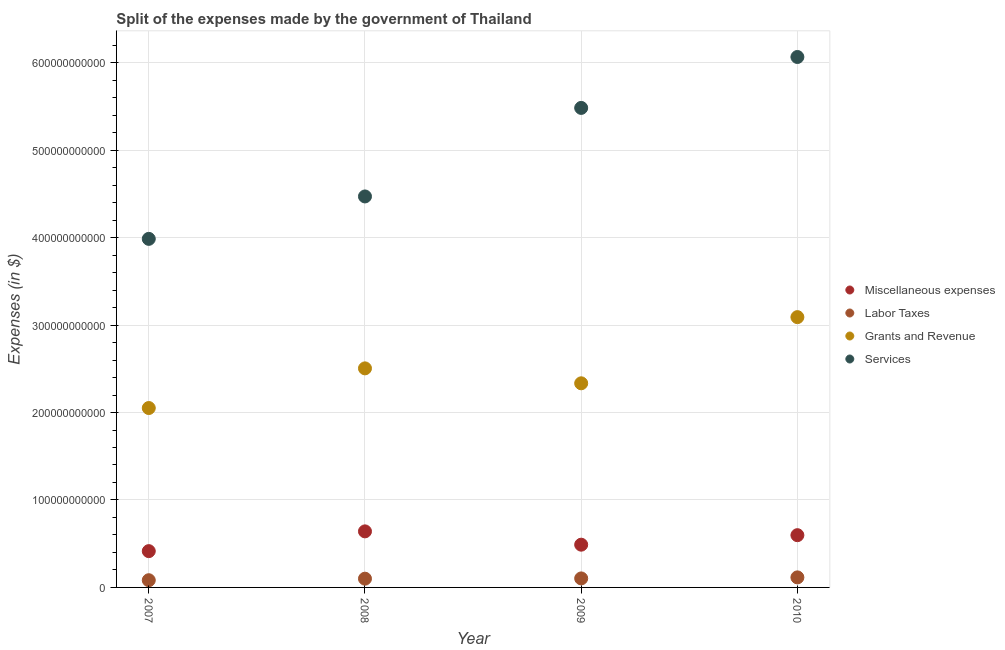Is the number of dotlines equal to the number of legend labels?
Your answer should be compact. Yes. Across all years, what is the maximum amount spent on labor taxes?
Make the answer very short. 1.15e+1. Across all years, what is the minimum amount spent on miscellaneous expenses?
Provide a short and direct response. 4.15e+1. In which year was the amount spent on services maximum?
Your answer should be very brief. 2010. In which year was the amount spent on miscellaneous expenses minimum?
Give a very brief answer. 2007. What is the total amount spent on labor taxes in the graph?
Your response must be concise. 4.00e+1. What is the difference between the amount spent on labor taxes in 2007 and that in 2008?
Your answer should be compact. -1.76e+09. What is the difference between the amount spent on services in 2010 and the amount spent on grants and revenue in 2008?
Your answer should be very brief. 3.56e+11. What is the average amount spent on miscellaneous expenses per year?
Give a very brief answer. 5.36e+1. In the year 2010, what is the difference between the amount spent on labor taxes and amount spent on miscellaneous expenses?
Provide a short and direct response. -4.83e+1. What is the ratio of the amount spent on grants and revenue in 2008 to that in 2010?
Provide a succinct answer. 0.81. Is the amount spent on miscellaneous expenses in 2008 less than that in 2010?
Your response must be concise. No. What is the difference between the highest and the second highest amount spent on services?
Provide a short and direct response. 5.82e+1. What is the difference between the highest and the lowest amount spent on labor taxes?
Give a very brief answer. 3.24e+09. Is the sum of the amount spent on labor taxes in 2009 and 2010 greater than the maximum amount spent on grants and revenue across all years?
Provide a succinct answer. No. Is it the case that in every year, the sum of the amount spent on miscellaneous expenses and amount spent on services is greater than the sum of amount spent on grants and revenue and amount spent on labor taxes?
Keep it short and to the point. Yes. Is it the case that in every year, the sum of the amount spent on miscellaneous expenses and amount spent on labor taxes is greater than the amount spent on grants and revenue?
Ensure brevity in your answer.  No. Does the amount spent on labor taxes monotonically increase over the years?
Your answer should be very brief. Yes. Is the amount spent on miscellaneous expenses strictly greater than the amount spent on labor taxes over the years?
Your answer should be very brief. Yes. Is the amount spent on labor taxes strictly less than the amount spent on miscellaneous expenses over the years?
Offer a terse response. Yes. How many dotlines are there?
Give a very brief answer. 4. What is the difference between two consecutive major ticks on the Y-axis?
Offer a very short reply. 1.00e+11. Does the graph contain any zero values?
Offer a terse response. No. Does the graph contain grids?
Provide a short and direct response. Yes. How many legend labels are there?
Provide a short and direct response. 4. How are the legend labels stacked?
Give a very brief answer. Vertical. What is the title of the graph?
Your answer should be compact. Split of the expenses made by the government of Thailand. What is the label or title of the X-axis?
Keep it short and to the point. Year. What is the label or title of the Y-axis?
Offer a terse response. Expenses (in $). What is the Expenses (in $) in Miscellaneous expenses in 2007?
Your answer should be very brief. 4.15e+1. What is the Expenses (in $) of Labor Taxes in 2007?
Your response must be concise. 8.24e+09. What is the Expenses (in $) of Grants and Revenue in 2007?
Provide a short and direct response. 2.05e+11. What is the Expenses (in $) of Services in 2007?
Your answer should be compact. 3.99e+11. What is the Expenses (in $) in Miscellaneous expenses in 2008?
Your answer should be very brief. 6.41e+1. What is the Expenses (in $) of Grants and Revenue in 2008?
Offer a terse response. 2.50e+11. What is the Expenses (in $) in Services in 2008?
Ensure brevity in your answer.  4.47e+11. What is the Expenses (in $) in Miscellaneous expenses in 2009?
Your answer should be very brief. 4.89e+1. What is the Expenses (in $) of Labor Taxes in 2009?
Provide a short and direct response. 1.03e+1. What is the Expenses (in $) in Grants and Revenue in 2009?
Provide a succinct answer. 2.33e+11. What is the Expenses (in $) of Services in 2009?
Keep it short and to the point. 5.48e+11. What is the Expenses (in $) of Miscellaneous expenses in 2010?
Ensure brevity in your answer.  5.98e+1. What is the Expenses (in $) of Labor Taxes in 2010?
Give a very brief answer. 1.15e+1. What is the Expenses (in $) in Grants and Revenue in 2010?
Provide a succinct answer. 3.09e+11. What is the Expenses (in $) in Services in 2010?
Keep it short and to the point. 6.07e+11. Across all years, what is the maximum Expenses (in $) of Miscellaneous expenses?
Keep it short and to the point. 6.41e+1. Across all years, what is the maximum Expenses (in $) in Labor Taxes?
Make the answer very short. 1.15e+1. Across all years, what is the maximum Expenses (in $) of Grants and Revenue?
Give a very brief answer. 3.09e+11. Across all years, what is the maximum Expenses (in $) of Services?
Your answer should be compact. 6.07e+11. Across all years, what is the minimum Expenses (in $) in Miscellaneous expenses?
Your response must be concise. 4.15e+1. Across all years, what is the minimum Expenses (in $) of Labor Taxes?
Keep it short and to the point. 8.24e+09. Across all years, what is the minimum Expenses (in $) of Grants and Revenue?
Provide a succinct answer. 2.05e+11. Across all years, what is the minimum Expenses (in $) in Services?
Provide a succinct answer. 3.99e+11. What is the total Expenses (in $) in Miscellaneous expenses in the graph?
Your response must be concise. 2.14e+11. What is the total Expenses (in $) in Labor Taxes in the graph?
Offer a terse response. 4.00e+1. What is the total Expenses (in $) in Grants and Revenue in the graph?
Provide a succinct answer. 9.98e+11. What is the total Expenses (in $) of Services in the graph?
Your answer should be very brief. 2.00e+12. What is the difference between the Expenses (in $) in Miscellaneous expenses in 2007 and that in 2008?
Offer a terse response. -2.26e+1. What is the difference between the Expenses (in $) in Labor Taxes in 2007 and that in 2008?
Your answer should be very brief. -1.76e+09. What is the difference between the Expenses (in $) of Grants and Revenue in 2007 and that in 2008?
Offer a terse response. -4.54e+1. What is the difference between the Expenses (in $) in Services in 2007 and that in 2008?
Provide a succinct answer. -4.85e+1. What is the difference between the Expenses (in $) in Miscellaneous expenses in 2007 and that in 2009?
Your response must be concise. -7.38e+09. What is the difference between the Expenses (in $) in Labor Taxes in 2007 and that in 2009?
Make the answer very short. -2.06e+09. What is the difference between the Expenses (in $) in Grants and Revenue in 2007 and that in 2009?
Keep it short and to the point. -2.83e+1. What is the difference between the Expenses (in $) in Services in 2007 and that in 2009?
Offer a very short reply. -1.50e+11. What is the difference between the Expenses (in $) of Miscellaneous expenses in 2007 and that in 2010?
Provide a short and direct response. -1.82e+1. What is the difference between the Expenses (in $) of Labor Taxes in 2007 and that in 2010?
Your answer should be very brief. -3.24e+09. What is the difference between the Expenses (in $) of Grants and Revenue in 2007 and that in 2010?
Give a very brief answer. -1.04e+11. What is the difference between the Expenses (in $) of Services in 2007 and that in 2010?
Offer a very short reply. -2.08e+11. What is the difference between the Expenses (in $) in Miscellaneous expenses in 2008 and that in 2009?
Provide a succinct answer. 1.52e+1. What is the difference between the Expenses (in $) of Labor Taxes in 2008 and that in 2009?
Offer a terse response. -3.00e+08. What is the difference between the Expenses (in $) in Grants and Revenue in 2008 and that in 2009?
Offer a terse response. 1.71e+1. What is the difference between the Expenses (in $) of Services in 2008 and that in 2009?
Offer a terse response. -1.01e+11. What is the difference between the Expenses (in $) of Miscellaneous expenses in 2008 and that in 2010?
Offer a terse response. 4.35e+09. What is the difference between the Expenses (in $) of Labor Taxes in 2008 and that in 2010?
Your answer should be compact. -1.48e+09. What is the difference between the Expenses (in $) in Grants and Revenue in 2008 and that in 2010?
Your answer should be compact. -5.86e+1. What is the difference between the Expenses (in $) of Services in 2008 and that in 2010?
Your answer should be compact. -1.59e+11. What is the difference between the Expenses (in $) of Miscellaneous expenses in 2009 and that in 2010?
Give a very brief answer. -1.09e+1. What is the difference between the Expenses (in $) of Labor Taxes in 2009 and that in 2010?
Give a very brief answer. -1.18e+09. What is the difference between the Expenses (in $) in Grants and Revenue in 2009 and that in 2010?
Provide a short and direct response. -7.57e+1. What is the difference between the Expenses (in $) of Services in 2009 and that in 2010?
Provide a short and direct response. -5.82e+1. What is the difference between the Expenses (in $) in Miscellaneous expenses in 2007 and the Expenses (in $) in Labor Taxes in 2008?
Your answer should be very brief. 3.15e+1. What is the difference between the Expenses (in $) in Miscellaneous expenses in 2007 and the Expenses (in $) in Grants and Revenue in 2008?
Your answer should be very brief. -2.09e+11. What is the difference between the Expenses (in $) of Miscellaneous expenses in 2007 and the Expenses (in $) of Services in 2008?
Ensure brevity in your answer.  -4.06e+11. What is the difference between the Expenses (in $) in Labor Taxes in 2007 and the Expenses (in $) in Grants and Revenue in 2008?
Your response must be concise. -2.42e+11. What is the difference between the Expenses (in $) in Labor Taxes in 2007 and the Expenses (in $) in Services in 2008?
Your answer should be very brief. -4.39e+11. What is the difference between the Expenses (in $) in Grants and Revenue in 2007 and the Expenses (in $) in Services in 2008?
Your answer should be very brief. -2.42e+11. What is the difference between the Expenses (in $) in Miscellaneous expenses in 2007 and the Expenses (in $) in Labor Taxes in 2009?
Offer a very short reply. 3.12e+1. What is the difference between the Expenses (in $) in Miscellaneous expenses in 2007 and the Expenses (in $) in Grants and Revenue in 2009?
Offer a terse response. -1.92e+11. What is the difference between the Expenses (in $) of Miscellaneous expenses in 2007 and the Expenses (in $) of Services in 2009?
Offer a very short reply. -5.07e+11. What is the difference between the Expenses (in $) in Labor Taxes in 2007 and the Expenses (in $) in Grants and Revenue in 2009?
Keep it short and to the point. -2.25e+11. What is the difference between the Expenses (in $) of Labor Taxes in 2007 and the Expenses (in $) of Services in 2009?
Provide a short and direct response. -5.40e+11. What is the difference between the Expenses (in $) in Grants and Revenue in 2007 and the Expenses (in $) in Services in 2009?
Your answer should be compact. -3.43e+11. What is the difference between the Expenses (in $) in Miscellaneous expenses in 2007 and the Expenses (in $) in Labor Taxes in 2010?
Keep it short and to the point. 3.00e+1. What is the difference between the Expenses (in $) of Miscellaneous expenses in 2007 and the Expenses (in $) of Grants and Revenue in 2010?
Make the answer very short. -2.68e+11. What is the difference between the Expenses (in $) of Miscellaneous expenses in 2007 and the Expenses (in $) of Services in 2010?
Ensure brevity in your answer.  -5.65e+11. What is the difference between the Expenses (in $) of Labor Taxes in 2007 and the Expenses (in $) of Grants and Revenue in 2010?
Offer a very short reply. -3.01e+11. What is the difference between the Expenses (in $) of Labor Taxes in 2007 and the Expenses (in $) of Services in 2010?
Offer a terse response. -5.98e+11. What is the difference between the Expenses (in $) in Grants and Revenue in 2007 and the Expenses (in $) in Services in 2010?
Your response must be concise. -4.01e+11. What is the difference between the Expenses (in $) in Miscellaneous expenses in 2008 and the Expenses (in $) in Labor Taxes in 2009?
Your answer should be compact. 5.38e+1. What is the difference between the Expenses (in $) of Miscellaneous expenses in 2008 and the Expenses (in $) of Grants and Revenue in 2009?
Your response must be concise. -1.69e+11. What is the difference between the Expenses (in $) in Miscellaneous expenses in 2008 and the Expenses (in $) in Services in 2009?
Your response must be concise. -4.84e+11. What is the difference between the Expenses (in $) in Labor Taxes in 2008 and the Expenses (in $) in Grants and Revenue in 2009?
Provide a succinct answer. -2.23e+11. What is the difference between the Expenses (in $) in Labor Taxes in 2008 and the Expenses (in $) in Services in 2009?
Your answer should be very brief. -5.38e+11. What is the difference between the Expenses (in $) in Grants and Revenue in 2008 and the Expenses (in $) in Services in 2009?
Your answer should be compact. -2.98e+11. What is the difference between the Expenses (in $) of Miscellaneous expenses in 2008 and the Expenses (in $) of Labor Taxes in 2010?
Ensure brevity in your answer.  5.26e+1. What is the difference between the Expenses (in $) in Miscellaneous expenses in 2008 and the Expenses (in $) in Grants and Revenue in 2010?
Your answer should be compact. -2.45e+11. What is the difference between the Expenses (in $) of Miscellaneous expenses in 2008 and the Expenses (in $) of Services in 2010?
Offer a very short reply. -5.42e+11. What is the difference between the Expenses (in $) of Labor Taxes in 2008 and the Expenses (in $) of Grants and Revenue in 2010?
Provide a succinct answer. -2.99e+11. What is the difference between the Expenses (in $) of Labor Taxes in 2008 and the Expenses (in $) of Services in 2010?
Give a very brief answer. -5.97e+11. What is the difference between the Expenses (in $) in Grants and Revenue in 2008 and the Expenses (in $) in Services in 2010?
Offer a very short reply. -3.56e+11. What is the difference between the Expenses (in $) in Miscellaneous expenses in 2009 and the Expenses (in $) in Labor Taxes in 2010?
Offer a terse response. 3.74e+1. What is the difference between the Expenses (in $) of Miscellaneous expenses in 2009 and the Expenses (in $) of Grants and Revenue in 2010?
Ensure brevity in your answer.  -2.60e+11. What is the difference between the Expenses (in $) in Miscellaneous expenses in 2009 and the Expenses (in $) in Services in 2010?
Provide a short and direct response. -5.58e+11. What is the difference between the Expenses (in $) of Labor Taxes in 2009 and the Expenses (in $) of Grants and Revenue in 2010?
Your response must be concise. -2.99e+11. What is the difference between the Expenses (in $) in Labor Taxes in 2009 and the Expenses (in $) in Services in 2010?
Give a very brief answer. -5.96e+11. What is the difference between the Expenses (in $) of Grants and Revenue in 2009 and the Expenses (in $) of Services in 2010?
Make the answer very short. -3.73e+11. What is the average Expenses (in $) in Miscellaneous expenses per year?
Provide a short and direct response. 5.36e+1. What is the average Expenses (in $) of Labor Taxes per year?
Your answer should be very brief. 1.00e+1. What is the average Expenses (in $) of Grants and Revenue per year?
Give a very brief answer. 2.50e+11. What is the average Expenses (in $) of Services per year?
Your response must be concise. 5.00e+11. In the year 2007, what is the difference between the Expenses (in $) in Miscellaneous expenses and Expenses (in $) in Labor Taxes?
Your answer should be compact. 3.33e+1. In the year 2007, what is the difference between the Expenses (in $) of Miscellaneous expenses and Expenses (in $) of Grants and Revenue?
Offer a very short reply. -1.64e+11. In the year 2007, what is the difference between the Expenses (in $) of Miscellaneous expenses and Expenses (in $) of Services?
Offer a very short reply. -3.57e+11. In the year 2007, what is the difference between the Expenses (in $) of Labor Taxes and Expenses (in $) of Grants and Revenue?
Make the answer very short. -1.97e+11. In the year 2007, what is the difference between the Expenses (in $) in Labor Taxes and Expenses (in $) in Services?
Ensure brevity in your answer.  -3.90e+11. In the year 2007, what is the difference between the Expenses (in $) of Grants and Revenue and Expenses (in $) of Services?
Provide a succinct answer. -1.93e+11. In the year 2008, what is the difference between the Expenses (in $) of Miscellaneous expenses and Expenses (in $) of Labor Taxes?
Your answer should be compact. 5.41e+1. In the year 2008, what is the difference between the Expenses (in $) in Miscellaneous expenses and Expenses (in $) in Grants and Revenue?
Make the answer very short. -1.86e+11. In the year 2008, what is the difference between the Expenses (in $) in Miscellaneous expenses and Expenses (in $) in Services?
Provide a succinct answer. -3.83e+11. In the year 2008, what is the difference between the Expenses (in $) in Labor Taxes and Expenses (in $) in Grants and Revenue?
Keep it short and to the point. -2.40e+11. In the year 2008, what is the difference between the Expenses (in $) of Labor Taxes and Expenses (in $) of Services?
Provide a short and direct response. -4.37e+11. In the year 2008, what is the difference between the Expenses (in $) of Grants and Revenue and Expenses (in $) of Services?
Provide a short and direct response. -1.97e+11. In the year 2009, what is the difference between the Expenses (in $) of Miscellaneous expenses and Expenses (in $) of Labor Taxes?
Offer a terse response. 3.86e+1. In the year 2009, what is the difference between the Expenses (in $) of Miscellaneous expenses and Expenses (in $) of Grants and Revenue?
Make the answer very short. -1.85e+11. In the year 2009, what is the difference between the Expenses (in $) in Miscellaneous expenses and Expenses (in $) in Services?
Offer a terse response. -4.99e+11. In the year 2009, what is the difference between the Expenses (in $) in Labor Taxes and Expenses (in $) in Grants and Revenue?
Ensure brevity in your answer.  -2.23e+11. In the year 2009, what is the difference between the Expenses (in $) of Labor Taxes and Expenses (in $) of Services?
Ensure brevity in your answer.  -5.38e+11. In the year 2009, what is the difference between the Expenses (in $) in Grants and Revenue and Expenses (in $) in Services?
Make the answer very short. -3.15e+11. In the year 2010, what is the difference between the Expenses (in $) in Miscellaneous expenses and Expenses (in $) in Labor Taxes?
Offer a terse response. 4.83e+1. In the year 2010, what is the difference between the Expenses (in $) of Miscellaneous expenses and Expenses (in $) of Grants and Revenue?
Keep it short and to the point. -2.49e+11. In the year 2010, what is the difference between the Expenses (in $) in Miscellaneous expenses and Expenses (in $) in Services?
Provide a succinct answer. -5.47e+11. In the year 2010, what is the difference between the Expenses (in $) of Labor Taxes and Expenses (in $) of Grants and Revenue?
Give a very brief answer. -2.98e+11. In the year 2010, what is the difference between the Expenses (in $) in Labor Taxes and Expenses (in $) in Services?
Keep it short and to the point. -5.95e+11. In the year 2010, what is the difference between the Expenses (in $) of Grants and Revenue and Expenses (in $) of Services?
Ensure brevity in your answer.  -2.97e+11. What is the ratio of the Expenses (in $) in Miscellaneous expenses in 2007 to that in 2008?
Your answer should be compact. 0.65. What is the ratio of the Expenses (in $) in Labor Taxes in 2007 to that in 2008?
Offer a very short reply. 0.82. What is the ratio of the Expenses (in $) in Grants and Revenue in 2007 to that in 2008?
Your response must be concise. 0.82. What is the ratio of the Expenses (in $) of Services in 2007 to that in 2008?
Your answer should be very brief. 0.89. What is the ratio of the Expenses (in $) in Miscellaneous expenses in 2007 to that in 2009?
Keep it short and to the point. 0.85. What is the ratio of the Expenses (in $) in Labor Taxes in 2007 to that in 2009?
Your response must be concise. 0.8. What is the ratio of the Expenses (in $) in Grants and Revenue in 2007 to that in 2009?
Give a very brief answer. 0.88. What is the ratio of the Expenses (in $) in Services in 2007 to that in 2009?
Your answer should be very brief. 0.73. What is the ratio of the Expenses (in $) of Miscellaneous expenses in 2007 to that in 2010?
Your response must be concise. 0.69. What is the ratio of the Expenses (in $) in Labor Taxes in 2007 to that in 2010?
Give a very brief answer. 0.72. What is the ratio of the Expenses (in $) of Grants and Revenue in 2007 to that in 2010?
Give a very brief answer. 0.66. What is the ratio of the Expenses (in $) of Services in 2007 to that in 2010?
Ensure brevity in your answer.  0.66. What is the ratio of the Expenses (in $) in Miscellaneous expenses in 2008 to that in 2009?
Your answer should be compact. 1.31. What is the ratio of the Expenses (in $) in Labor Taxes in 2008 to that in 2009?
Your answer should be compact. 0.97. What is the ratio of the Expenses (in $) of Grants and Revenue in 2008 to that in 2009?
Provide a succinct answer. 1.07. What is the ratio of the Expenses (in $) in Services in 2008 to that in 2009?
Your answer should be compact. 0.82. What is the ratio of the Expenses (in $) in Miscellaneous expenses in 2008 to that in 2010?
Provide a succinct answer. 1.07. What is the ratio of the Expenses (in $) in Labor Taxes in 2008 to that in 2010?
Your answer should be very brief. 0.87. What is the ratio of the Expenses (in $) in Grants and Revenue in 2008 to that in 2010?
Your answer should be compact. 0.81. What is the ratio of the Expenses (in $) of Services in 2008 to that in 2010?
Your answer should be compact. 0.74. What is the ratio of the Expenses (in $) in Miscellaneous expenses in 2009 to that in 2010?
Give a very brief answer. 0.82. What is the ratio of the Expenses (in $) of Labor Taxes in 2009 to that in 2010?
Your answer should be compact. 0.9. What is the ratio of the Expenses (in $) in Grants and Revenue in 2009 to that in 2010?
Your answer should be very brief. 0.76. What is the ratio of the Expenses (in $) of Services in 2009 to that in 2010?
Your answer should be very brief. 0.9. What is the difference between the highest and the second highest Expenses (in $) in Miscellaneous expenses?
Give a very brief answer. 4.35e+09. What is the difference between the highest and the second highest Expenses (in $) of Labor Taxes?
Provide a succinct answer. 1.18e+09. What is the difference between the highest and the second highest Expenses (in $) of Grants and Revenue?
Make the answer very short. 5.86e+1. What is the difference between the highest and the second highest Expenses (in $) of Services?
Offer a terse response. 5.82e+1. What is the difference between the highest and the lowest Expenses (in $) in Miscellaneous expenses?
Your response must be concise. 2.26e+1. What is the difference between the highest and the lowest Expenses (in $) of Labor Taxes?
Provide a succinct answer. 3.24e+09. What is the difference between the highest and the lowest Expenses (in $) in Grants and Revenue?
Keep it short and to the point. 1.04e+11. What is the difference between the highest and the lowest Expenses (in $) in Services?
Offer a terse response. 2.08e+11. 